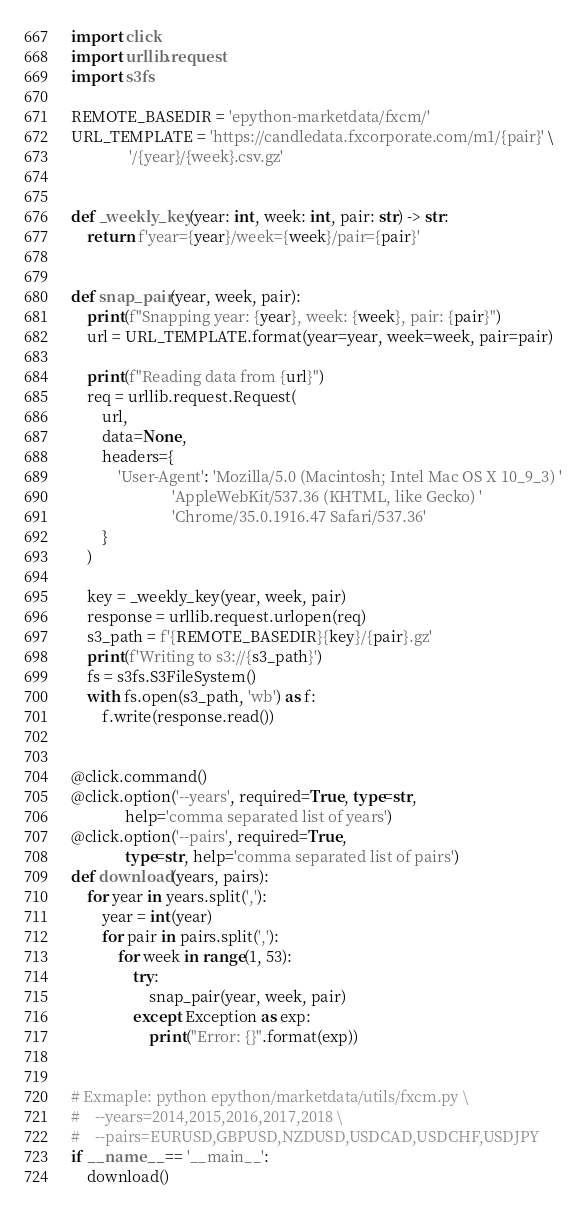Convert code to text. <code><loc_0><loc_0><loc_500><loc_500><_Python_>import click
import urllib.request
import s3fs

REMOTE_BASEDIR = 'epython-marketdata/fxcm/'
URL_TEMPLATE = 'https://candledata.fxcorporate.com/m1/{pair}' \
               '/{year}/{week}.csv.gz'


def _weekly_key(year: int, week: int, pair: str) -> str:
    return f'year={year}/week={week}/pair={pair}'


def snap_pair(year, week, pair):
    print(f"Snapping year: {year}, week: {week}, pair: {pair}")
    url = URL_TEMPLATE.format(year=year, week=week, pair=pair)

    print(f"Reading data from {url}")
    req = urllib.request.Request(
        url,
        data=None,
        headers={
            'User-Agent': 'Mozilla/5.0 (Macintosh; Intel Mac OS X 10_9_3) '
                          'AppleWebKit/537.36 (KHTML, like Gecko) '
                          'Chrome/35.0.1916.47 Safari/537.36'
        }
    )

    key = _weekly_key(year, week, pair)
    response = urllib.request.urlopen(req)
    s3_path = f'{REMOTE_BASEDIR}{key}/{pair}.gz'
    print(f'Writing to s3://{s3_path}')
    fs = s3fs.S3FileSystem()
    with fs.open(s3_path, 'wb') as f:
        f.write(response.read())


@click.command()
@click.option('--years', required=True, type=str,
              help='comma separated list of years')
@click.option('--pairs', required=True,
              type=str, help='comma separated list of pairs')
def download(years, pairs):
    for year in years.split(','):
        year = int(year)
        for pair in pairs.split(','):
            for week in range(1, 53):
                try:
                    snap_pair(year, week, pair)
                except Exception as exp:
                    print("Error: {}".format(exp))


# Exmaple: python epython/marketdata/utils/fxcm.py \
#    --years=2014,2015,2016,2017,2018 \
#    --pairs=EURUSD,GBPUSD,NZDUSD,USDCAD,USDCHF,USDJPY
if __name__ == '__main__':
    download()
</code> 